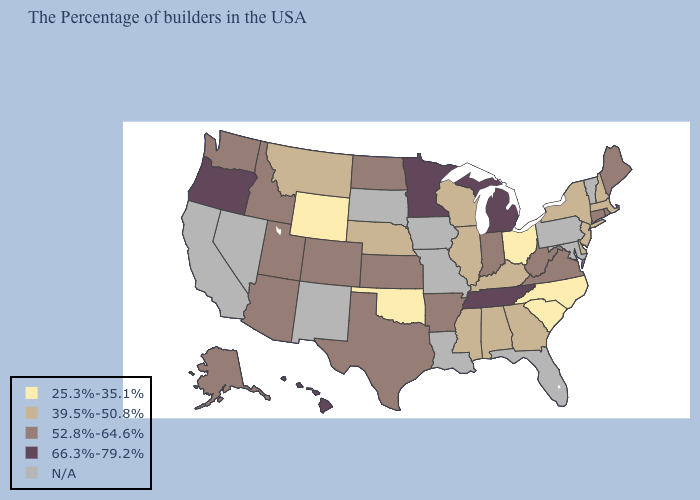Name the states that have a value in the range 52.8%-64.6%?
Concise answer only. Maine, Rhode Island, Connecticut, Virginia, West Virginia, Indiana, Arkansas, Kansas, Texas, North Dakota, Colorado, Utah, Arizona, Idaho, Washington, Alaska. Does the map have missing data?
Short answer required. Yes. Name the states that have a value in the range N/A?
Write a very short answer. Vermont, Maryland, Pennsylvania, Florida, Louisiana, Missouri, Iowa, South Dakota, New Mexico, Nevada, California. Among the states that border Michigan , does Indiana have the lowest value?
Give a very brief answer. No. What is the value of Alabama?
Short answer required. 39.5%-50.8%. Name the states that have a value in the range 52.8%-64.6%?
Answer briefly. Maine, Rhode Island, Connecticut, Virginia, West Virginia, Indiana, Arkansas, Kansas, Texas, North Dakota, Colorado, Utah, Arizona, Idaho, Washington, Alaska. What is the value of New Jersey?
Keep it brief. 39.5%-50.8%. Name the states that have a value in the range N/A?
Answer briefly. Vermont, Maryland, Pennsylvania, Florida, Louisiana, Missouri, Iowa, South Dakota, New Mexico, Nevada, California. Which states have the lowest value in the South?
Keep it brief. North Carolina, South Carolina, Oklahoma. What is the lowest value in the West?
Write a very short answer. 25.3%-35.1%. Name the states that have a value in the range 39.5%-50.8%?
Be succinct. Massachusetts, New Hampshire, New York, New Jersey, Delaware, Georgia, Kentucky, Alabama, Wisconsin, Illinois, Mississippi, Nebraska, Montana. What is the value of Montana?
Answer briefly. 39.5%-50.8%. Which states hav the highest value in the MidWest?
Keep it brief. Michigan, Minnesota. 